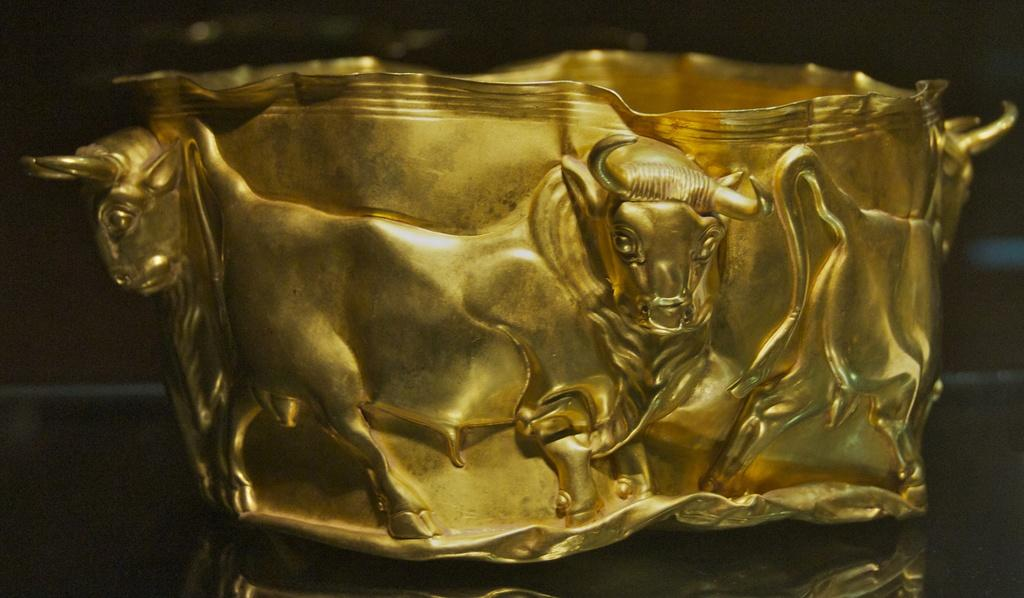What material is the object made of in the image? The object is made of metal. What color is the object in the image? The object has a gold color. What design can be seen on the object? There is a design of bulls on the object. What type of cracker is being used to decorate the object in the image? There is no cracker present in the image, and therefore no such decoration can be observed. 